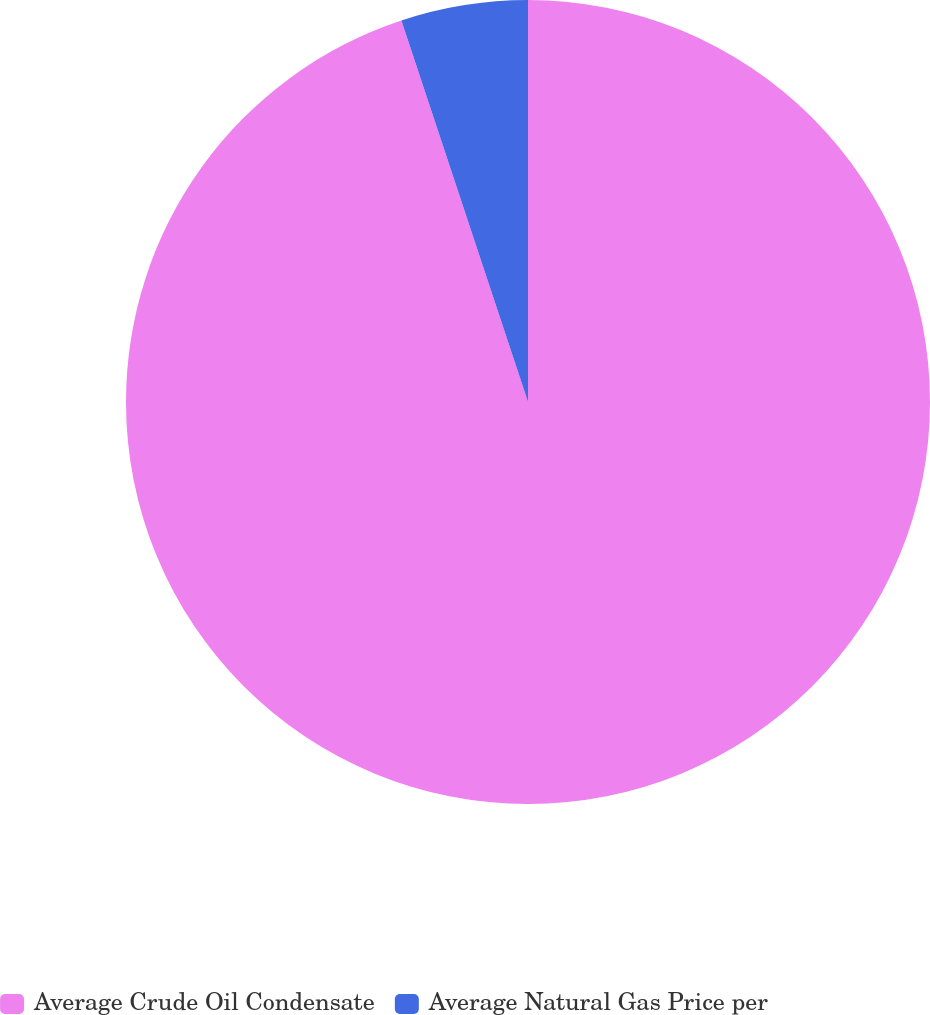<chart> <loc_0><loc_0><loc_500><loc_500><pie_chart><fcel>Average Crude Oil Condensate<fcel>Average Natural Gas Price per<nl><fcel>94.9%<fcel>5.1%<nl></chart> 